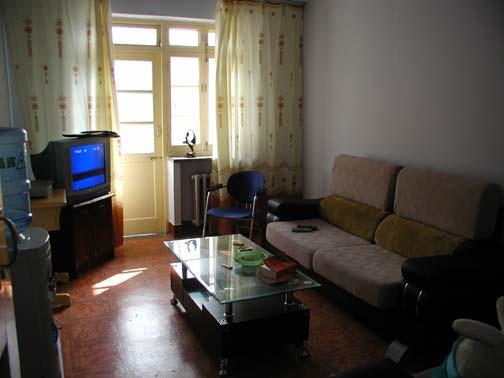Is the sun shining?
Short answer required. Yes. Is the TV a latest model?
Answer briefly. No. What channel is the TV on?
Quick response, please. 3. 